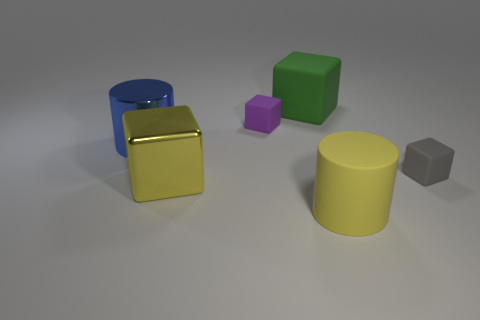Add 4 small cyan shiny cylinders. How many objects exist? 10 Subtract all gray matte cubes. How many cubes are left? 3 Subtract 1 cubes. How many cubes are left? 3 Subtract all purple cubes. How many cubes are left? 3 Subtract all cylinders. How many objects are left? 4 Subtract all gray cubes. Subtract all red cylinders. How many cubes are left? 3 Subtract all small things. Subtract all large metallic blocks. How many objects are left? 3 Add 6 small gray things. How many small gray things are left? 7 Add 5 large brown matte cubes. How many large brown matte cubes exist? 5 Subtract 0 yellow spheres. How many objects are left? 6 